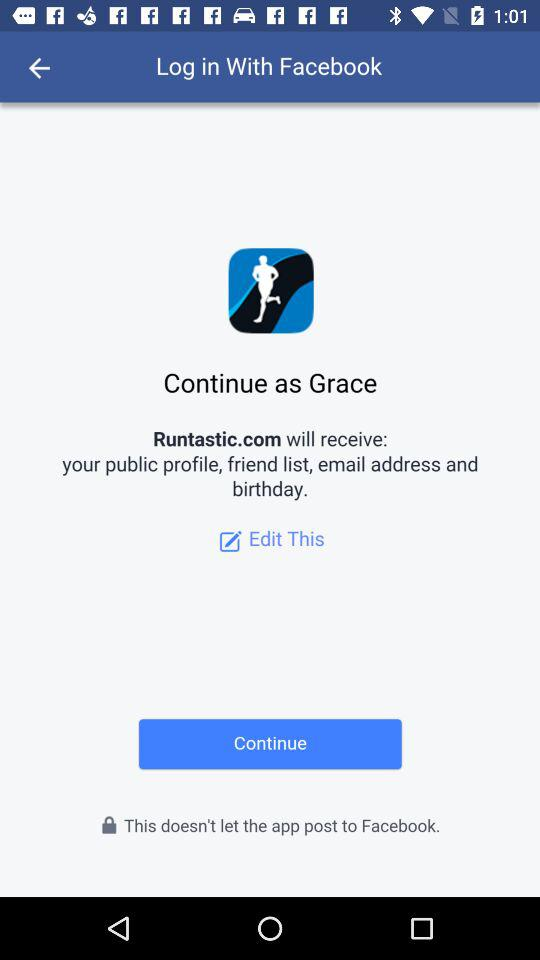What application is used for login? The application is "Log in with Facebook". 